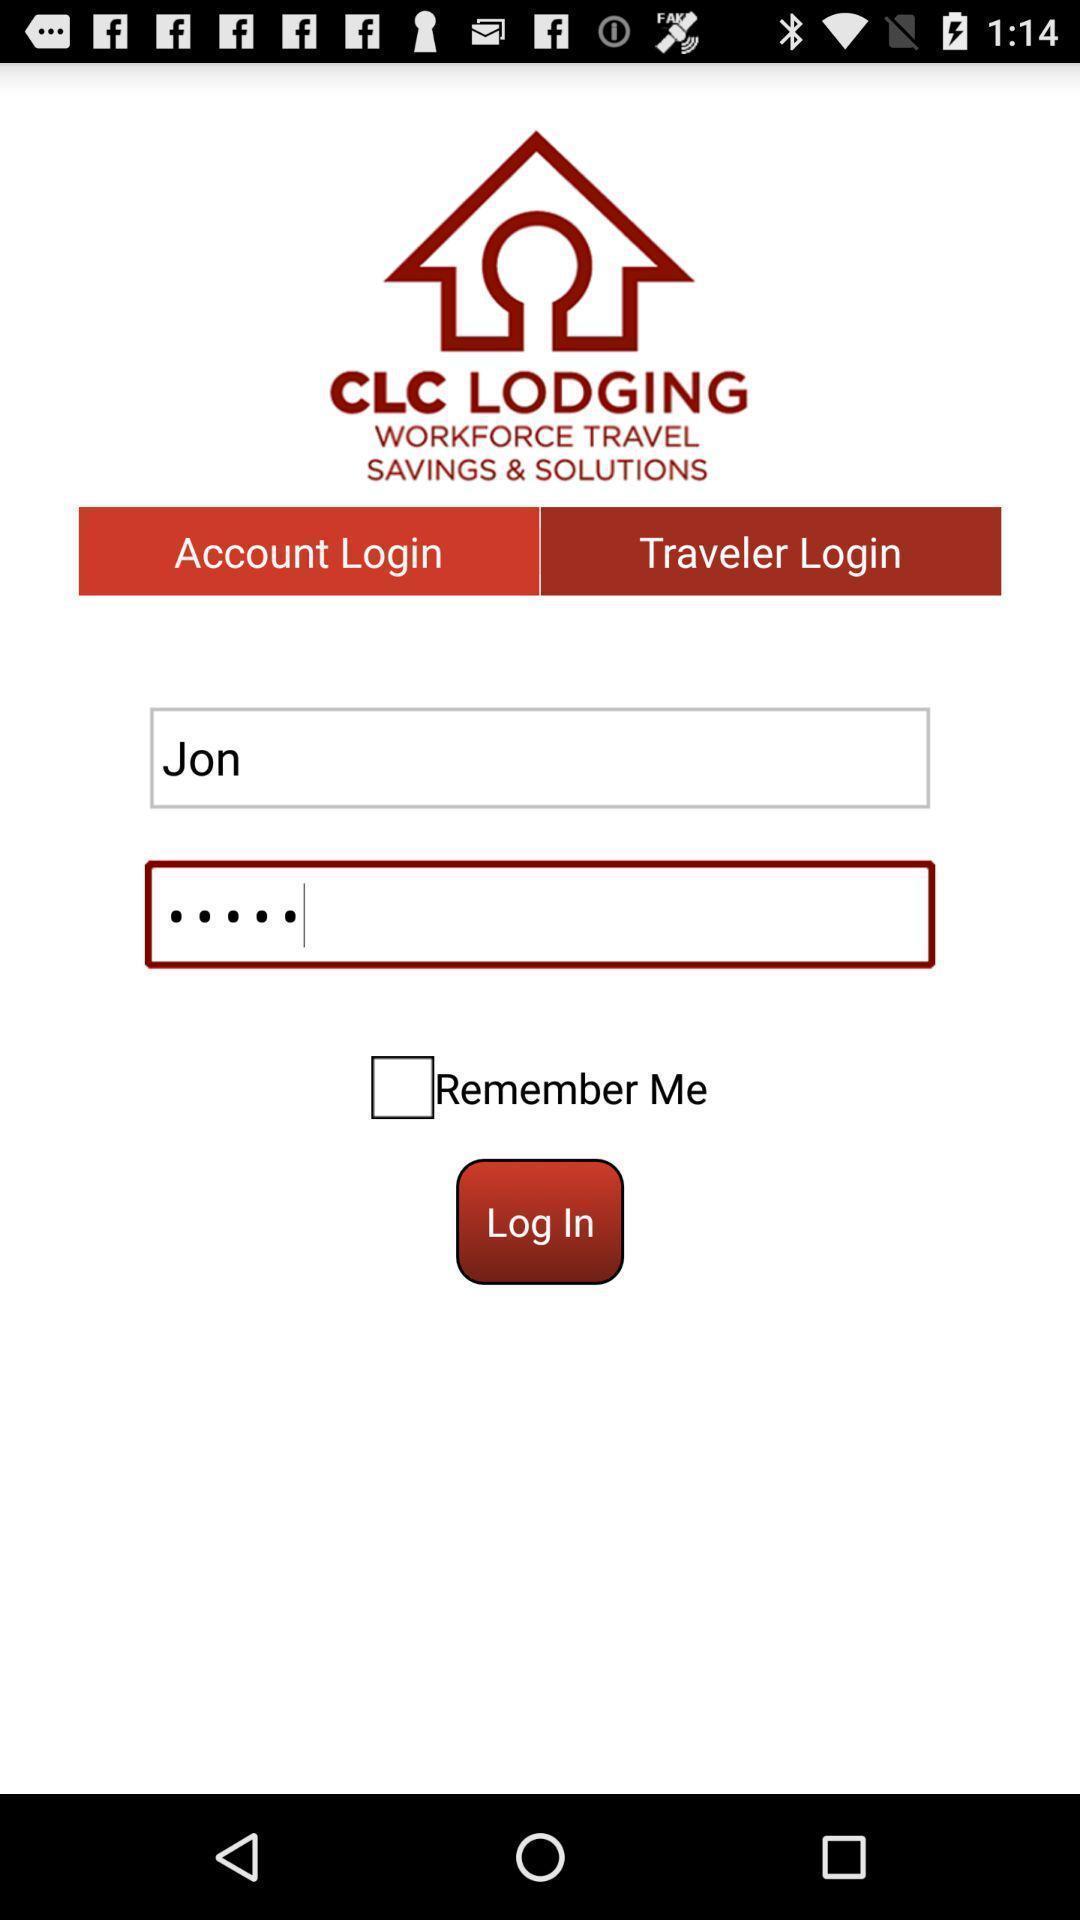What is the overall content of this screenshot? Screen displaying the login page. 